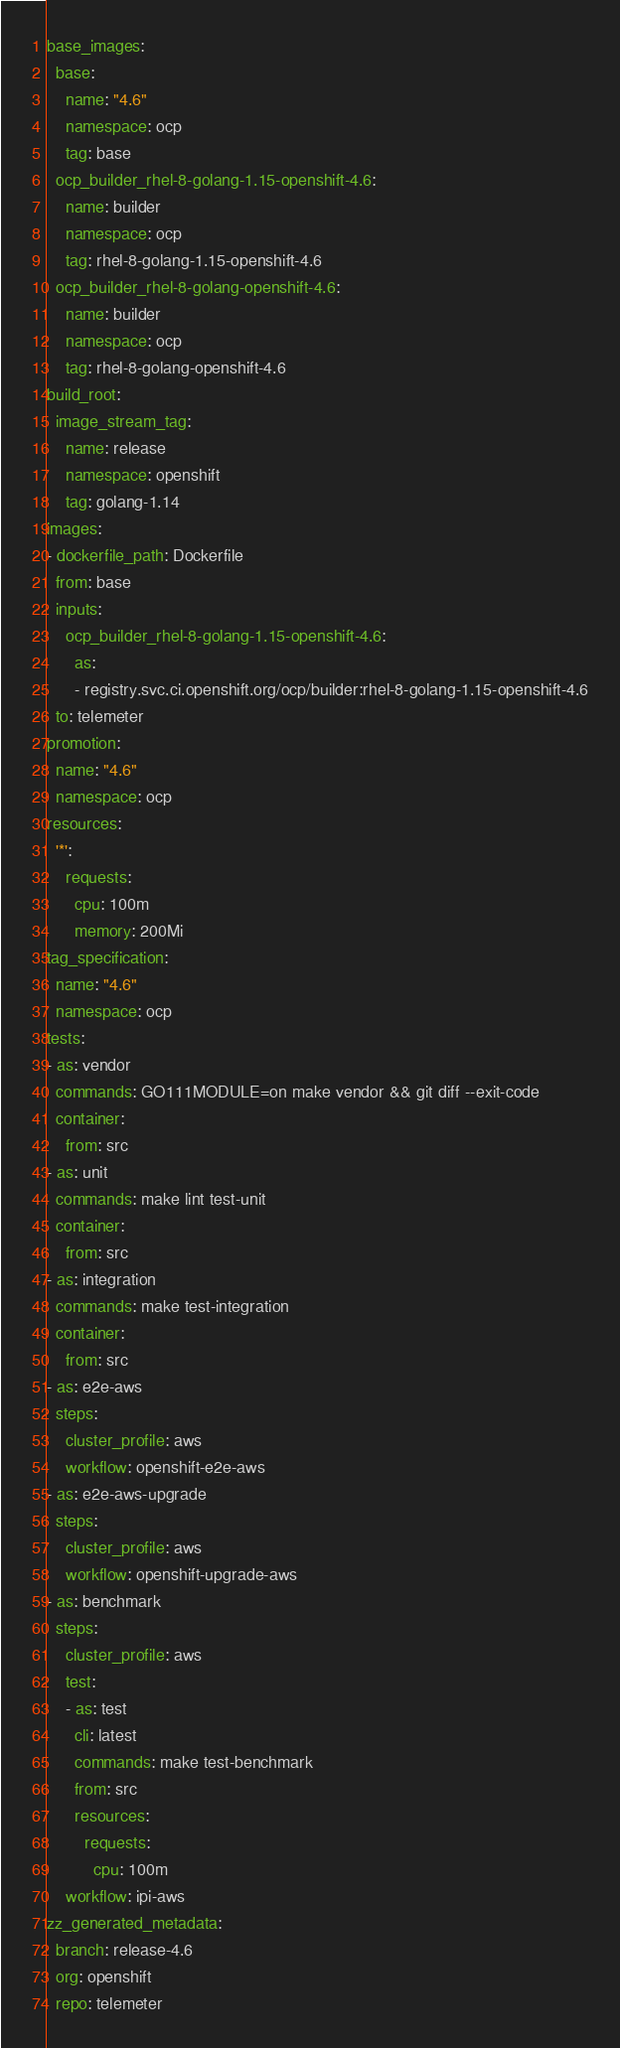<code> <loc_0><loc_0><loc_500><loc_500><_YAML_>base_images:
  base:
    name: "4.6"
    namespace: ocp
    tag: base
  ocp_builder_rhel-8-golang-1.15-openshift-4.6:
    name: builder
    namespace: ocp
    tag: rhel-8-golang-1.15-openshift-4.6
  ocp_builder_rhel-8-golang-openshift-4.6:
    name: builder
    namespace: ocp
    tag: rhel-8-golang-openshift-4.6
build_root:
  image_stream_tag:
    name: release
    namespace: openshift
    tag: golang-1.14
images:
- dockerfile_path: Dockerfile
  from: base
  inputs:
    ocp_builder_rhel-8-golang-1.15-openshift-4.6:
      as:
      - registry.svc.ci.openshift.org/ocp/builder:rhel-8-golang-1.15-openshift-4.6
  to: telemeter
promotion:
  name: "4.6"
  namespace: ocp
resources:
  '*':
    requests:
      cpu: 100m
      memory: 200Mi
tag_specification:
  name: "4.6"
  namespace: ocp
tests:
- as: vendor
  commands: GO111MODULE=on make vendor && git diff --exit-code
  container:
    from: src
- as: unit
  commands: make lint test-unit
  container:
    from: src
- as: integration
  commands: make test-integration
  container:
    from: src
- as: e2e-aws
  steps:
    cluster_profile: aws
    workflow: openshift-e2e-aws
- as: e2e-aws-upgrade
  steps:
    cluster_profile: aws
    workflow: openshift-upgrade-aws
- as: benchmark
  steps:
    cluster_profile: aws
    test:
    - as: test
      cli: latest
      commands: make test-benchmark
      from: src
      resources:
        requests:
          cpu: 100m
    workflow: ipi-aws
zz_generated_metadata:
  branch: release-4.6
  org: openshift
  repo: telemeter
</code> 